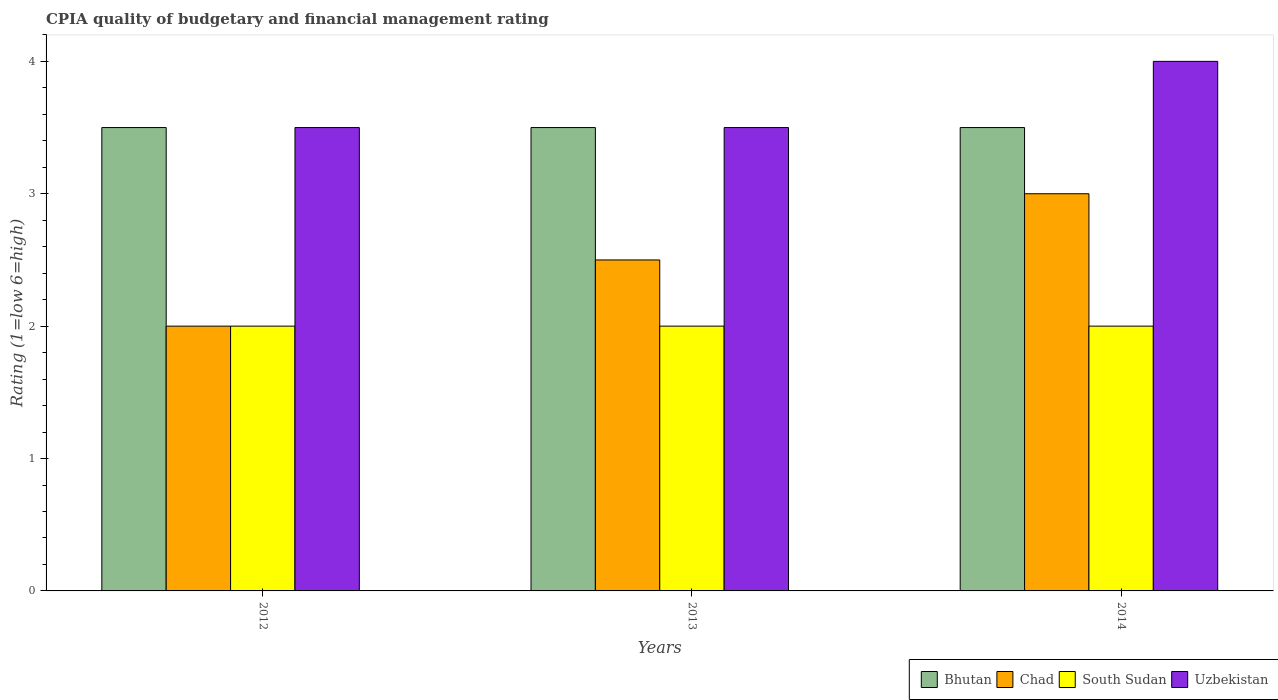How many groups of bars are there?
Your answer should be very brief. 3. Are the number of bars per tick equal to the number of legend labels?
Make the answer very short. Yes. How many bars are there on the 2nd tick from the left?
Provide a short and direct response. 4. How many bars are there on the 1st tick from the right?
Offer a very short reply. 4. What is the CPIA rating in South Sudan in 2014?
Your response must be concise. 2. Across all years, what is the minimum CPIA rating in Bhutan?
Ensure brevity in your answer.  3.5. In which year was the CPIA rating in Uzbekistan maximum?
Keep it short and to the point. 2014. In which year was the CPIA rating in Bhutan minimum?
Make the answer very short. 2012. What is the total CPIA rating in South Sudan in the graph?
Your response must be concise. 6. What is the average CPIA rating in South Sudan per year?
Provide a succinct answer. 2. In how many years, is the CPIA rating in Chad greater than 0.4?
Offer a very short reply. 3. Is the CPIA rating in Bhutan in 2012 less than that in 2014?
Offer a terse response. No. Is the difference between the CPIA rating in Bhutan in 2012 and 2014 greater than the difference between the CPIA rating in Chad in 2012 and 2014?
Ensure brevity in your answer.  Yes. What is the difference between the highest and the lowest CPIA rating in Chad?
Give a very brief answer. 1. Is it the case that in every year, the sum of the CPIA rating in Bhutan and CPIA rating in Uzbekistan is greater than the sum of CPIA rating in Chad and CPIA rating in South Sudan?
Keep it short and to the point. Yes. What does the 4th bar from the left in 2012 represents?
Your answer should be compact. Uzbekistan. What does the 4th bar from the right in 2012 represents?
Provide a short and direct response. Bhutan. Is it the case that in every year, the sum of the CPIA rating in Uzbekistan and CPIA rating in Bhutan is greater than the CPIA rating in South Sudan?
Your answer should be very brief. Yes. How many bars are there?
Provide a short and direct response. 12. Are all the bars in the graph horizontal?
Give a very brief answer. No. How many years are there in the graph?
Make the answer very short. 3. What is the difference between two consecutive major ticks on the Y-axis?
Your answer should be very brief. 1. Does the graph contain any zero values?
Your response must be concise. No. How many legend labels are there?
Your answer should be very brief. 4. What is the title of the graph?
Your answer should be very brief. CPIA quality of budgetary and financial management rating. Does "Central African Republic" appear as one of the legend labels in the graph?
Your answer should be compact. No. What is the label or title of the X-axis?
Your answer should be compact. Years. What is the label or title of the Y-axis?
Give a very brief answer. Rating (1=low 6=high). What is the Rating (1=low 6=high) in South Sudan in 2012?
Offer a very short reply. 2. What is the Rating (1=low 6=high) in Uzbekistan in 2012?
Provide a succinct answer. 3.5. What is the Rating (1=low 6=high) in Bhutan in 2013?
Provide a succinct answer. 3.5. What is the Rating (1=low 6=high) in Chad in 2013?
Make the answer very short. 2.5. What is the Rating (1=low 6=high) of Uzbekistan in 2013?
Make the answer very short. 3.5. What is the Rating (1=low 6=high) in Chad in 2014?
Ensure brevity in your answer.  3. Across all years, what is the minimum Rating (1=low 6=high) of Chad?
Provide a short and direct response. 2. What is the total Rating (1=low 6=high) in Uzbekistan in the graph?
Keep it short and to the point. 11. What is the difference between the Rating (1=low 6=high) of Bhutan in 2012 and that in 2013?
Ensure brevity in your answer.  0. What is the difference between the Rating (1=low 6=high) in Chad in 2012 and that in 2013?
Ensure brevity in your answer.  -0.5. What is the difference between the Rating (1=low 6=high) in South Sudan in 2012 and that in 2013?
Keep it short and to the point. 0. What is the difference between the Rating (1=low 6=high) in Uzbekistan in 2012 and that in 2013?
Ensure brevity in your answer.  0. What is the difference between the Rating (1=low 6=high) of Bhutan in 2012 and that in 2014?
Your answer should be compact. 0. What is the difference between the Rating (1=low 6=high) in South Sudan in 2012 and that in 2014?
Your answer should be very brief. 0. What is the difference between the Rating (1=low 6=high) of Uzbekistan in 2012 and that in 2014?
Your response must be concise. -0.5. What is the difference between the Rating (1=low 6=high) of Chad in 2013 and that in 2014?
Offer a terse response. -0.5. What is the difference between the Rating (1=low 6=high) of South Sudan in 2013 and that in 2014?
Offer a very short reply. 0. What is the difference between the Rating (1=low 6=high) in Bhutan in 2012 and the Rating (1=low 6=high) in Chad in 2013?
Keep it short and to the point. 1. What is the difference between the Rating (1=low 6=high) of Bhutan in 2012 and the Rating (1=low 6=high) of South Sudan in 2013?
Your answer should be very brief. 1.5. What is the difference between the Rating (1=low 6=high) of Chad in 2012 and the Rating (1=low 6=high) of Uzbekistan in 2013?
Provide a short and direct response. -1.5. What is the difference between the Rating (1=low 6=high) of South Sudan in 2012 and the Rating (1=low 6=high) of Uzbekistan in 2013?
Make the answer very short. -1.5. What is the difference between the Rating (1=low 6=high) in Bhutan in 2012 and the Rating (1=low 6=high) in Uzbekistan in 2014?
Provide a succinct answer. -0.5. What is the difference between the Rating (1=low 6=high) in Chad in 2012 and the Rating (1=low 6=high) in Uzbekistan in 2014?
Provide a succinct answer. -2. What is the difference between the Rating (1=low 6=high) in South Sudan in 2012 and the Rating (1=low 6=high) in Uzbekistan in 2014?
Your answer should be very brief. -2. What is the difference between the Rating (1=low 6=high) in Bhutan in 2013 and the Rating (1=low 6=high) in South Sudan in 2014?
Your response must be concise. 1.5. What is the difference between the Rating (1=low 6=high) of Chad in 2013 and the Rating (1=low 6=high) of South Sudan in 2014?
Your answer should be compact. 0.5. What is the difference between the Rating (1=low 6=high) of Chad in 2013 and the Rating (1=low 6=high) of Uzbekistan in 2014?
Provide a succinct answer. -1.5. What is the average Rating (1=low 6=high) in Uzbekistan per year?
Make the answer very short. 3.67. In the year 2012, what is the difference between the Rating (1=low 6=high) in Bhutan and Rating (1=low 6=high) in Uzbekistan?
Provide a short and direct response. 0. In the year 2012, what is the difference between the Rating (1=low 6=high) in Chad and Rating (1=low 6=high) in Uzbekistan?
Ensure brevity in your answer.  -1.5. In the year 2012, what is the difference between the Rating (1=low 6=high) in South Sudan and Rating (1=low 6=high) in Uzbekistan?
Your response must be concise. -1.5. In the year 2013, what is the difference between the Rating (1=low 6=high) of Bhutan and Rating (1=low 6=high) of South Sudan?
Offer a terse response. 1.5. In the year 2013, what is the difference between the Rating (1=low 6=high) of Bhutan and Rating (1=low 6=high) of Uzbekistan?
Offer a terse response. 0. In the year 2013, what is the difference between the Rating (1=low 6=high) in South Sudan and Rating (1=low 6=high) in Uzbekistan?
Ensure brevity in your answer.  -1.5. In the year 2014, what is the difference between the Rating (1=low 6=high) in Bhutan and Rating (1=low 6=high) in South Sudan?
Ensure brevity in your answer.  1.5. In the year 2014, what is the difference between the Rating (1=low 6=high) in Bhutan and Rating (1=low 6=high) in Uzbekistan?
Give a very brief answer. -0.5. In the year 2014, what is the difference between the Rating (1=low 6=high) in Chad and Rating (1=low 6=high) in Uzbekistan?
Keep it short and to the point. -1. In the year 2014, what is the difference between the Rating (1=low 6=high) of South Sudan and Rating (1=low 6=high) of Uzbekistan?
Keep it short and to the point. -2. What is the ratio of the Rating (1=low 6=high) of Bhutan in 2012 to that in 2013?
Ensure brevity in your answer.  1. What is the ratio of the Rating (1=low 6=high) of Chad in 2012 to that in 2013?
Offer a very short reply. 0.8. What is the ratio of the Rating (1=low 6=high) in Uzbekistan in 2012 to that in 2013?
Give a very brief answer. 1. What is the ratio of the Rating (1=low 6=high) in Chad in 2012 to that in 2014?
Keep it short and to the point. 0.67. What is the ratio of the Rating (1=low 6=high) of South Sudan in 2012 to that in 2014?
Your answer should be very brief. 1. What is the ratio of the Rating (1=low 6=high) of Chad in 2013 to that in 2014?
Make the answer very short. 0.83. What is the ratio of the Rating (1=low 6=high) in South Sudan in 2013 to that in 2014?
Give a very brief answer. 1. What is the ratio of the Rating (1=low 6=high) of Uzbekistan in 2013 to that in 2014?
Provide a succinct answer. 0.88. What is the difference between the highest and the second highest Rating (1=low 6=high) in South Sudan?
Your answer should be compact. 0. What is the difference between the highest and the lowest Rating (1=low 6=high) in Bhutan?
Offer a very short reply. 0. What is the difference between the highest and the lowest Rating (1=low 6=high) in South Sudan?
Your answer should be very brief. 0. What is the difference between the highest and the lowest Rating (1=low 6=high) of Uzbekistan?
Ensure brevity in your answer.  0.5. 